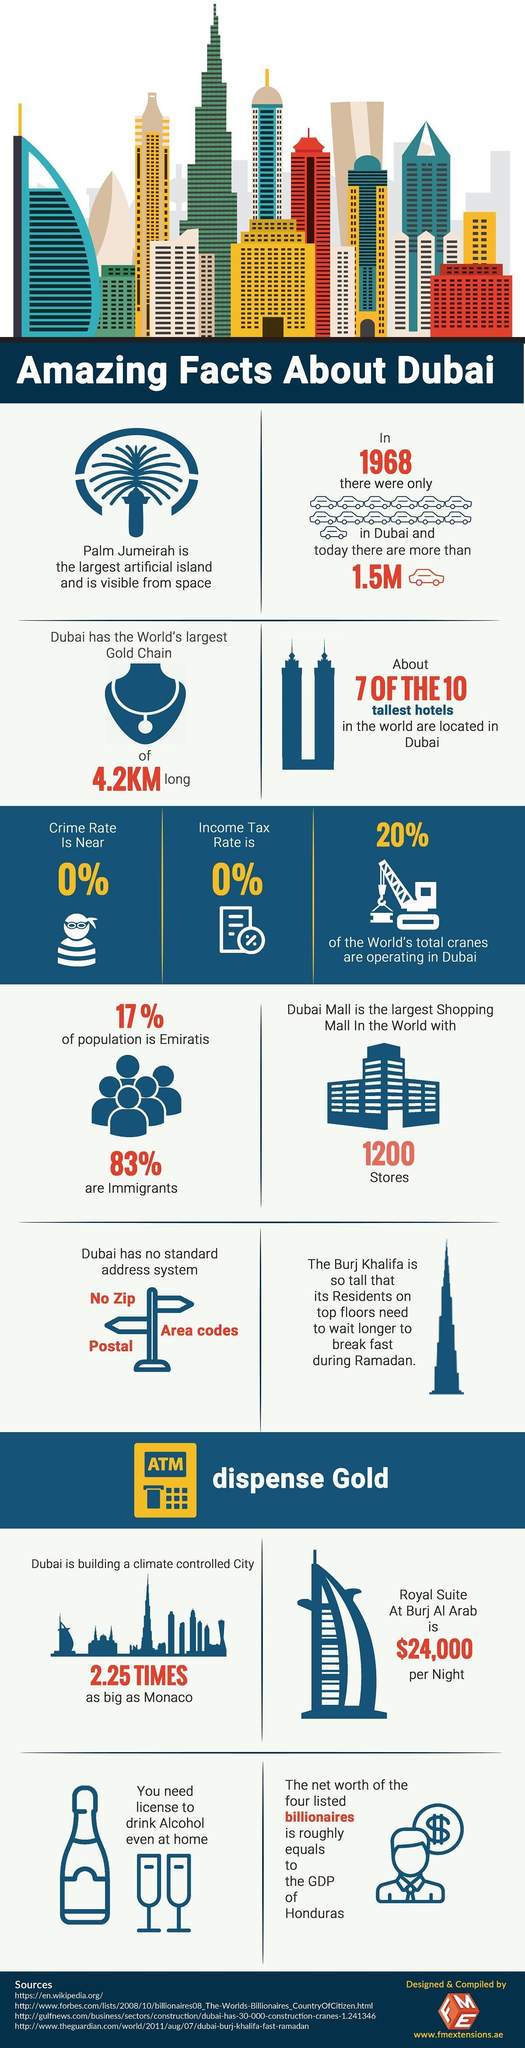Mention a couple of crucial points in this snapshot. Dubai currently has a population of more than 1.5 million cars. The gold chain has a length of 4.2 kilometers. 